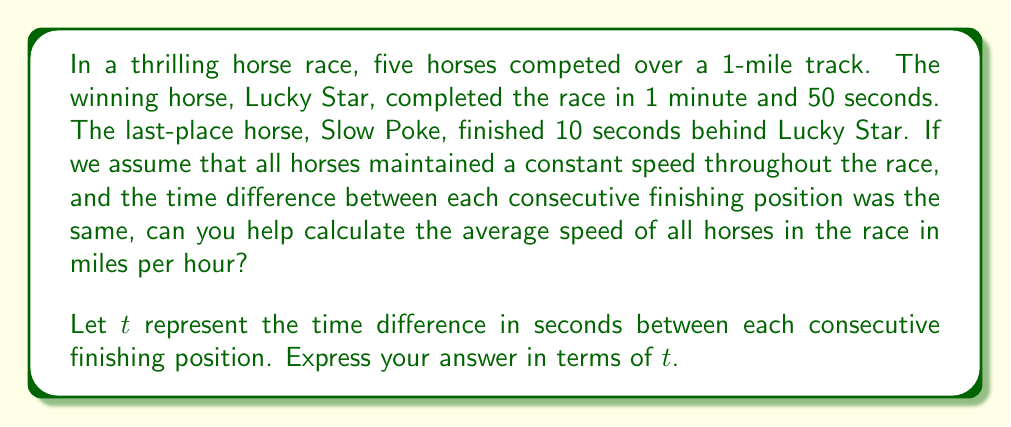Teach me how to tackle this problem. Let's break this down step-by-step:

1) First, we need to calculate the times for all horses:
   - Lucky Star: 1 minute 50 seconds = 110 seconds
   - Second place: 110 + $t$ seconds
   - Third place: 110 + 2$t$ seconds
   - Fourth place: 110 + 3$t$ seconds
   - Slow Poke: 110 + 4$t$ = 120 seconds (given in the question)

2) From the last point, we can deduce:
   $$110 + 4t = 120$$
   $$4t = 10$$
   $$t = 2.5 \text{ seconds}$$

3) Now we have all the finishing times:
   - 110, 112.5, 115, 117.5, 120 seconds

4) To find the average speed, we need the average time:
   $$\text{Average time} = \frac{110 + 112.5 + 115 + 117.5 + 120}{5} = 115 \text{ seconds}$$

5) Now we can calculate the average speed:
   $$\text{Speed} = \frac{\text{Distance}}{\text{Time}}$$
   
   The distance is 1 mile and the time is 115 seconds.
   
   $$\text{Speed} = \frac{1 \text{ mile}}{115 \text{ seconds}} = \frac{3600}{115} \text{ miles per hour}$$

6) To express this in terms of $t$:
   Average time = $110 + 2t$ seconds
   
   $$\text{Average Speed} = \frac{3600}{110 + 2t} \text{ miles per hour}$$

This is our final answer in terms of $t$.
Answer: The average speed of all horses in the race is $\frac{3600}{110 + 2t}$ miles per hour, where $t$ is the time difference in seconds between each consecutive finishing position. 